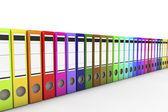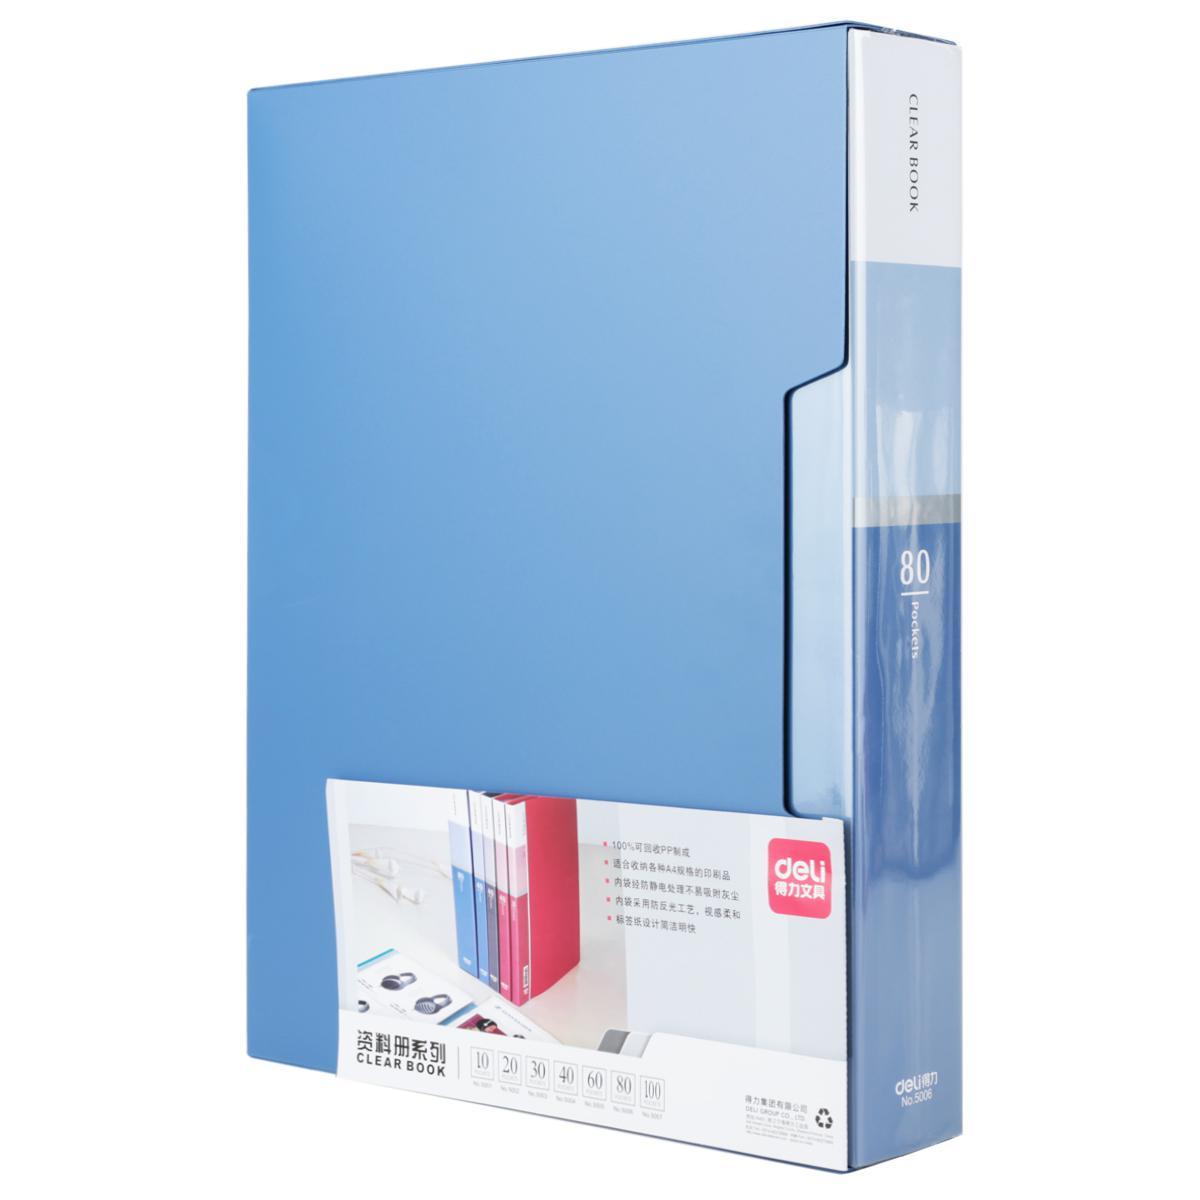The first image is the image on the left, the second image is the image on the right. For the images displayed, is the sentence "At least one image shows binders lying on their sides, in a kind of stack." factually correct? Answer yes or no. No. The first image is the image on the left, the second image is the image on the right. Given the left and right images, does the statement "There is one binder in the the image on the right." hold true? Answer yes or no. Yes. 